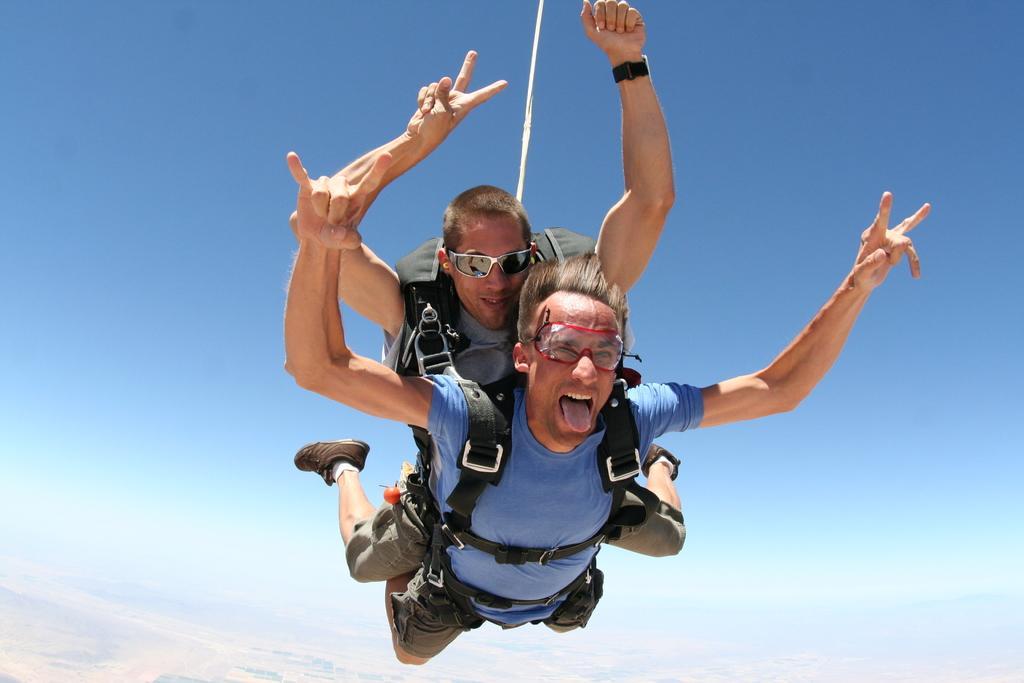Describe this image in one or two sentences. In this image there are two men who are flying in the air by wearing the parachute. They are lying on one above the other. 